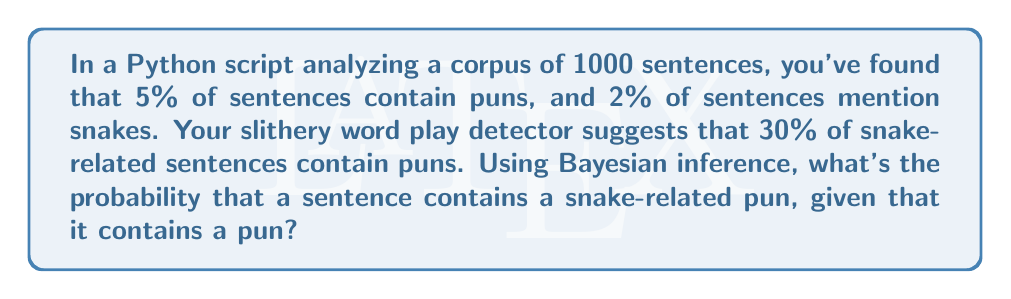Teach me how to tackle this problem. Let's approach this step-by-step using Bayesian inference:

1. Define our events:
   A: Sentence contains a pun
   B: Sentence mentions snakes

2. Given probabilities:
   $P(A) = 0.05$ (5% of sentences contain puns)
   $P(B) = 0.02$ (2% of sentences mention snakes)
   $P(A|B) = 0.30$ (30% of snake-related sentences contain puns)

3. We want to find $P(B|A)$, the probability of a sentence mentioning snakes given that it contains a pun.

4. Bayes' theorem states:

   $$P(B|A) = \frac{P(A|B) \cdot P(B)}{P(A)}$$

5. We know $P(A|B)$, $P(B)$, and $P(A)$. Let's substitute these values:

   $$P(B|A) = \frac{0.30 \cdot 0.02}{0.05}$$

6. Simplify:
   $$P(B|A) = \frac{0.006}{0.05} = 0.12$$

7. Convert to a percentage:
   $0.12 \cdot 100\% = 12\%$
Answer: 12% 